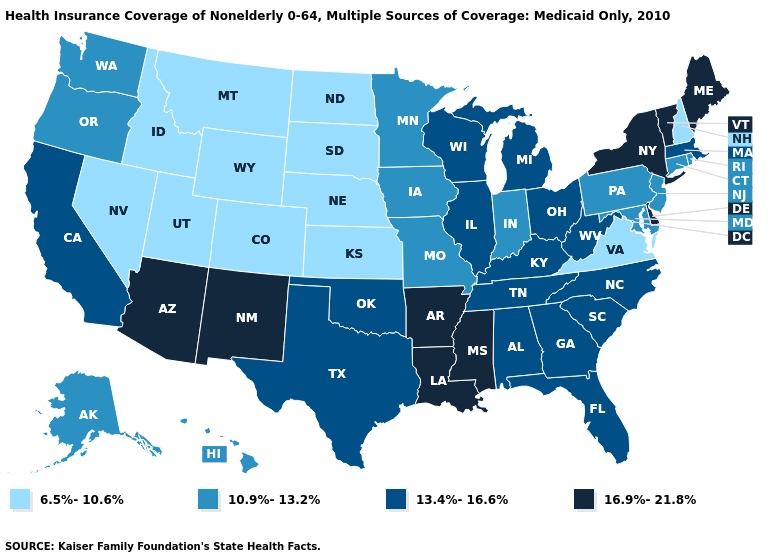Among the states that border West Virginia , does Ohio have the highest value?
Keep it brief. Yes. What is the value of Maryland?
Give a very brief answer. 10.9%-13.2%. How many symbols are there in the legend?
Write a very short answer. 4. Name the states that have a value in the range 10.9%-13.2%?
Concise answer only. Alaska, Connecticut, Hawaii, Indiana, Iowa, Maryland, Minnesota, Missouri, New Jersey, Oregon, Pennsylvania, Rhode Island, Washington. What is the value of Arizona?
Keep it brief. 16.9%-21.8%. What is the lowest value in the South?
Quick response, please. 6.5%-10.6%. What is the lowest value in the MidWest?
Give a very brief answer. 6.5%-10.6%. Does Vermont have the highest value in the Northeast?
Answer briefly. Yes. Does North Dakota have a higher value than Colorado?
Write a very short answer. No. Name the states that have a value in the range 13.4%-16.6%?
Give a very brief answer. Alabama, California, Florida, Georgia, Illinois, Kentucky, Massachusetts, Michigan, North Carolina, Ohio, Oklahoma, South Carolina, Tennessee, Texas, West Virginia, Wisconsin. Which states have the highest value in the USA?
Answer briefly. Arizona, Arkansas, Delaware, Louisiana, Maine, Mississippi, New Mexico, New York, Vermont. What is the value of Connecticut?
Quick response, please. 10.9%-13.2%. Does West Virginia have the highest value in the South?
Answer briefly. No. Which states have the lowest value in the USA?
Be succinct. Colorado, Idaho, Kansas, Montana, Nebraska, Nevada, New Hampshire, North Dakota, South Dakota, Utah, Virginia, Wyoming. Is the legend a continuous bar?
Concise answer only. No. 